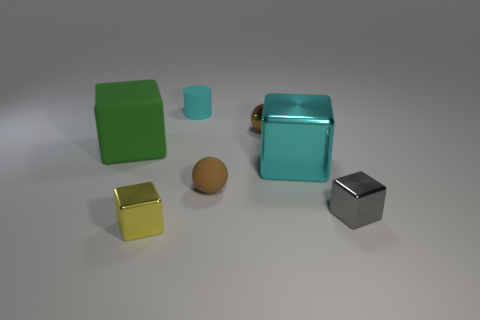Subtract all gray blocks. Subtract all green cylinders. How many blocks are left? 3 Add 2 tiny cyan rubber cylinders. How many objects exist? 9 Subtract all balls. How many objects are left? 5 Add 4 matte cubes. How many matte cubes are left? 5 Add 6 tiny cyan rubber cylinders. How many tiny cyan rubber cylinders exist? 7 Subtract 0 blue spheres. How many objects are left? 7 Subtract all tiny red things. Subtract all cyan blocks. How many objects are left? 6 